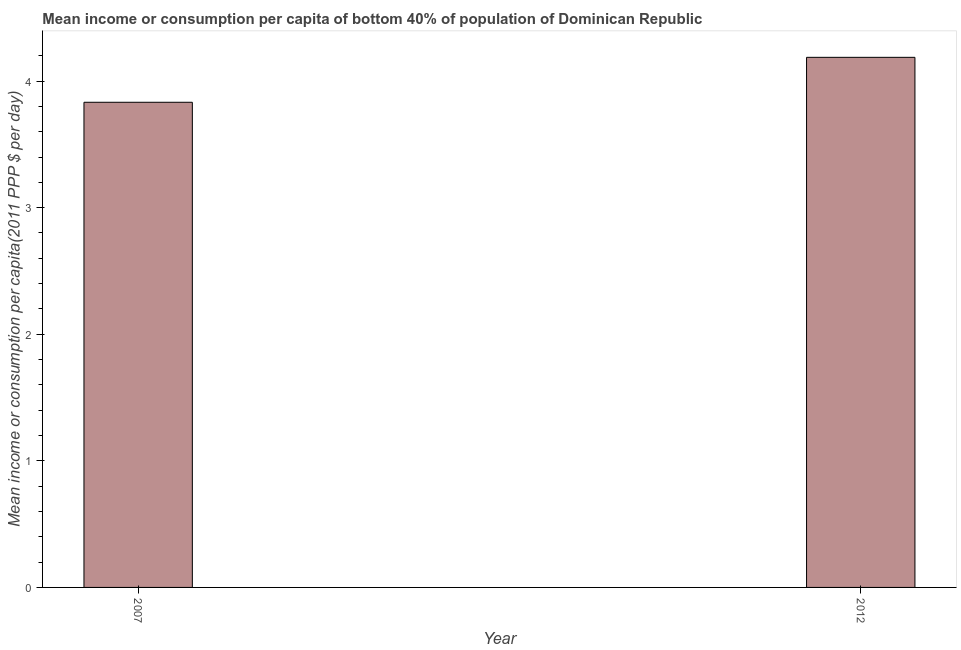What is the title of the graph?
Give a very brief answer. Mean income or consumption per capita of bottom 40% of population of Dominican Republic. What is the label or title of the X-axis?
Keep it short and to the point. Year. What is the label or title of the Y-axis?
Your answer should be compact. Mean income or consumption per capita(2011 PPP $ per day). What is the mean income or consumption in 2007?
Offer a very short reply. 3.83. Across all years, what is the maximum mean income or consumption?
Give a very brief answer. 4.19. Across all years, what is the minimum mean income or consumption?
Your answer should be very brief. 3.83. In which year was the mean income or consumption maximum?
Your answer should be very brief. 2012. What is the sum of the mean income or consumption?
Provide a succinct answer. 8.02. What is the difference between the mean income or consumption in 2007 and 2012?
Offer a very short reply. -0.35. What is the average mean income or consumption per year?
Provide a succinct answer. 4.01. What is the median mean income or consumption?
Make the answer very short. 4.01. What is the ratio of the mean income or consumption in 2007 to that in 2012?
Provide a succinct answer. 0.92. Is the mean income or consumption in 2007 less than that in 2012?
Give a very brief answer. Yes. In how many years, is the mean income or consumption greater than the average mean income or consumption taken over all years?
Keep it short and to the point. 1. How many bars are there?
Your answer should be very brief. 2. Are all the bars in the graph horizontal?
Keep it short and to the point. No. How many years are there in the graph?
Offer a very short reply. 2. What is the Mean income or consumption per capita(2011 PPP $ per day) in 2007?
Offer a terse response. 3.83. What is the Mean income or consumption per capita(2011 PPP $ per day) of 2012?
Give a very brief answer. 4.19. What is the difference between the Mean income or consumption per capita(2011 PPP $ per day) in 2007 and 2012?
Offer a terse response. -0.36. What is the ratio of the Mean income or consumption per capita(2011 PPP $ per day) in 2007 to that in 2012?
Offer a terse response. 0.92. 